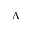<formula> <loc_0><loc_0><loc_500><loc_500>\Lambda</formula> 